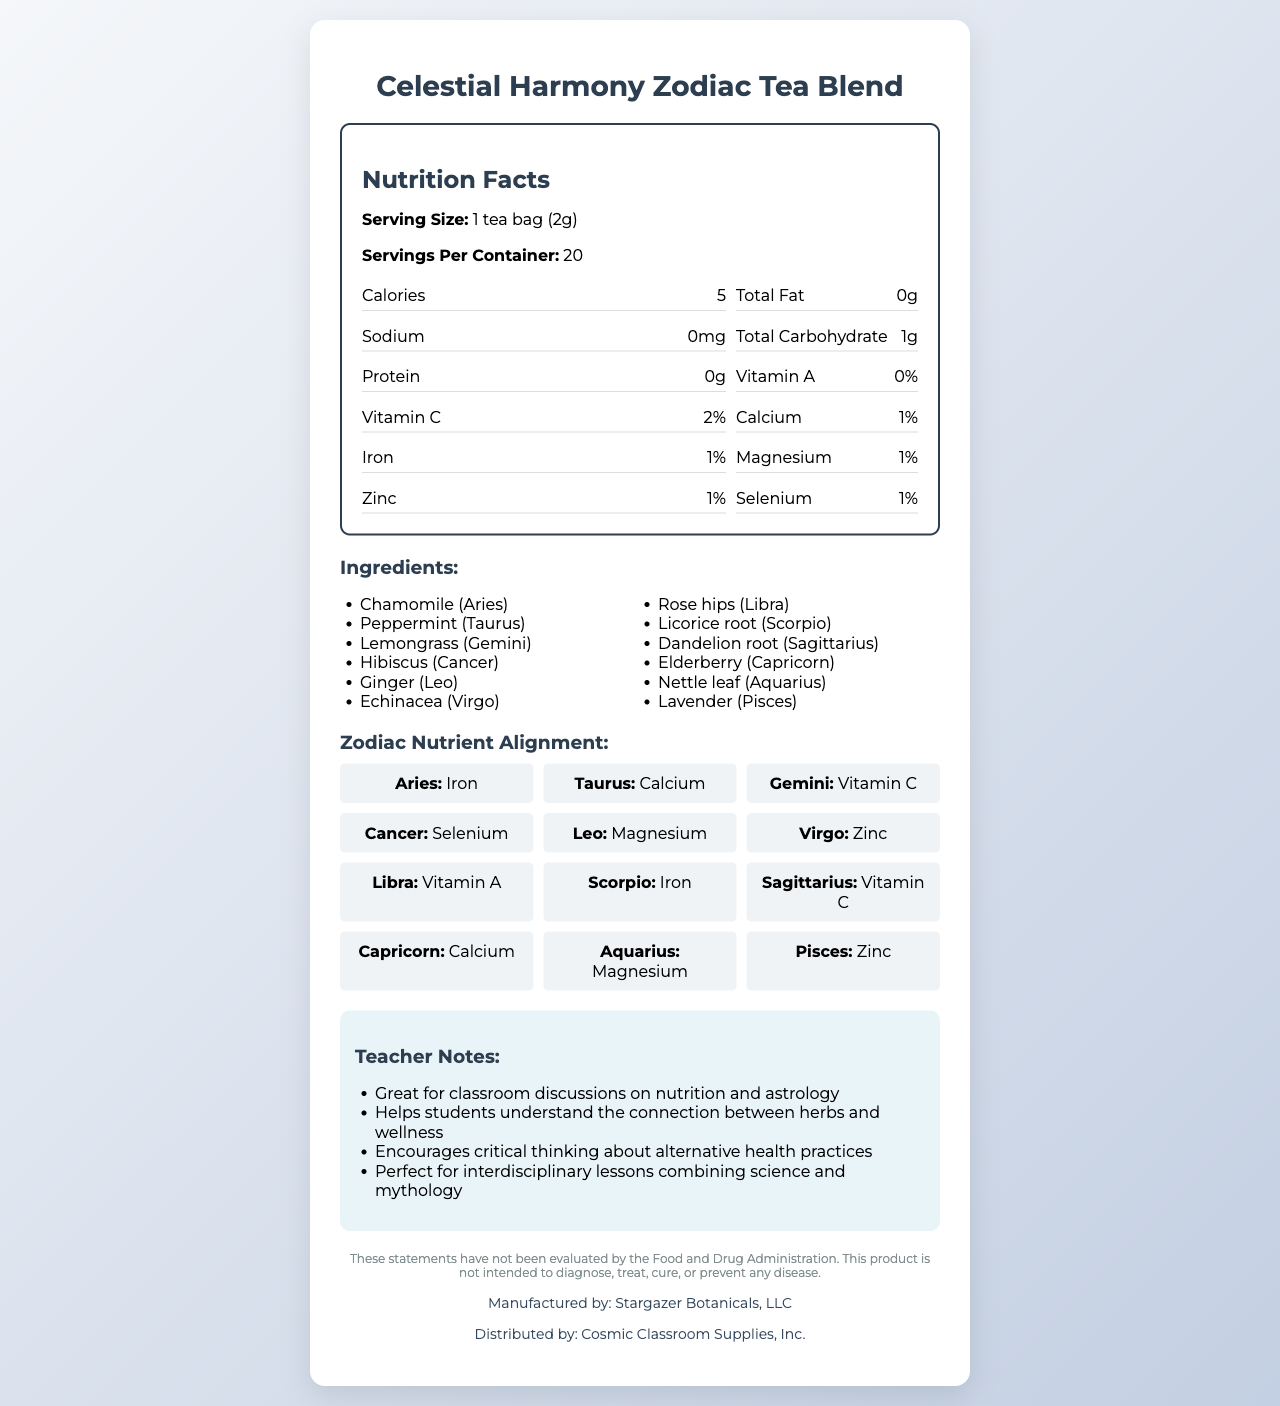what is the serving size of Celestial Harmony Zodiac Tea Blend? The serving size information is clearly listed as "1 tea bag (2g)".
Answer: 1 tea bag (2g) how many servings are in one container of the tea blend? The document states that there are 20 servings per container.
Answer: 20 what are the calories per serving? The Nutrition Facts section lists the calories as 5 per serving.
Answer: 5 which zodiac sign is associated with chamomile? The ingredients section shows "Chamomile (Aries)".
Answer: Aries how much vitamin C is in one serving of the tea? The Nutrition Facts lists the amount of Vitamin C as 2%.
Answer: 2% which nutrient is aligned with the Aquarius zodiac sign? The Zodiac Nutrient Alignment section shows that Aquarius is aligned with Magnesium.
Answer: Magnesium which herb is associated with the Libra zodiac sign? The ingredients section indicates "Rose hips (Libra)".
Answer: Rose hips what is the total fat content in one serving of the tea? The Nutrition Facts section lists the total fat content as 0g per serving.
Answer: 0g are there any statements regarding FDA evaluation in the document? There is a disclaimer stating that the statements have not been evaluated by the FDA.
Answer: Yes who manufactures the Celestial Harmony Zodiac Tea Blend? The manufacturer information is listed as "Stargazer Botanicals, LLC".
Answer: Stargazer Botanicals, LLC which zodiac sign is associated with Vitamin C? A. Aries B. Gemini C. Leo D. Scorpio The Zodiac Nutrient Alignment section shows that Gemini is aligned with Vitamin C.
Answer: B. Gemini which nutrient is not listed in the Nutrition Facts? I. Vitamin A II. Vitamin C III. Calcium IV. Potassium Potassium is not listed in the Nutrition Facts section of the document.
Answer: IV. Potassium is there any sodium in one serving of the tea? The Nutrition Facts section shows that the sodium content is 0mg per serving.
Answer: No provide a summary of the main idea of the document The document is a comprehensive overview of the product's nutrition facts, ingredients, zodiac alignment, and includes teacher notes, a disclaimer about FDA evaluation, and manufacturer information.
Answer: The document provides detailed nutritional information and ingredient lists for the "Celestial Harmony Zodiac Tea Blend", including serving size, calories, and nutrient content. It aligns each herb in the blend with a zodiac sign and illustrates the corresponding nutrients. Teacher notes offer insights for classroom discussions on nutrition and astrology. It also includes a disclaimer about FDA evaluation, and notes the manufacturer and distributor of the product. what is the percentage of zinc in one serving of the tea? The Nutrition Facts section indicates Zinc content as 1%.
Answer: 1% which zodiac sign is associated with the herb lemongrass? The ingredients section states "Lemongrass (Gemini)".
Answer: Gemini how much iron is in one serving of Celestial Harmony Zodiac Tea Blend? The Nutrition Facts section lists the iron content as 1%.
Answer: 1% what is the carbohydrate content in one serving? The Nutrition Facts section shows the total carbohydrate content as 1g.
Answer: 1g what is the relationship between astrology and the ingredients in the tea blend? The Zodiac Nutrient Alignment section and the ingredients list show how each herb aligns with a specific zodiac sign and nutrient.
Answer: The herbs in the tea blend are each associated with a specific zodiac sign and aligned with a corresponding nutrient. are the statements about the tea blend evaluated by the FDA? The disclaimer clearly states that the statements have not been evaluated by the FDA.
Answer: No how are the teacher notes relevant to classroom discussions? The teacher notes section mentions that the tea blend is great for discussions on nutrition and astrology and helps understand the connection between herbs and wellness, encouraging critical thinking.
Answer: They provide ideas for discussions on the connection between herbs, wellness, and astrology, and encourage critical thinking about alternative health practices. how much protein does one serving of the tea provide? The Nutrition Facts section lists the protein content as 0g.
Answer: 0g why is the nutrient alignment with the zodiac signs considered interesting? The combination of astrology and nutrition can provide a unique and engaging way to present the product, as reflected in the Zodiac Nutrient Alignment section.
Answer: It combines elements of astrology with nutrition, potentially making the product more appealing and engaging for those interested in both fields. what is the role of the manufactured by and distributed by information? The manufacturer information is listed as "Stargazer Botanicals, LLC" and the distributor as "Cosmic Classroom Supplies, Inc."
Answer: It provides details about who manufactures and distributes the Celestial Harmony Zodiac Tea Blend, ensuring transparency and accountability. 